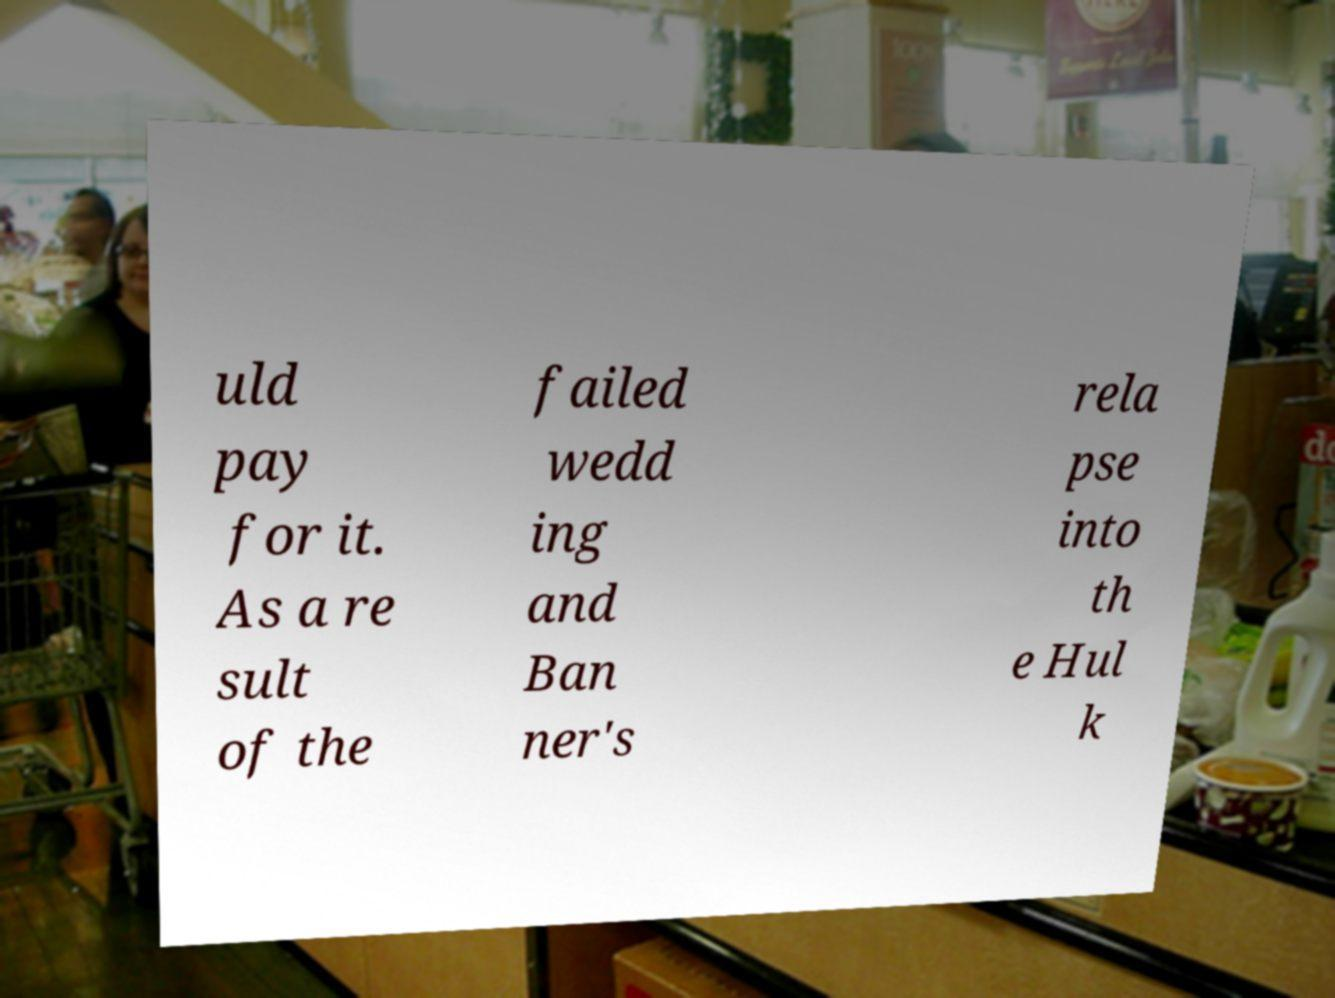Can you read and provide the text displayed in the image?This photo seems to have some interesting text. Can you extract and type it out for me? uld pay for it. As a re sult of the failed wedd ing and Ban ner's rela pse into th e Hul k 